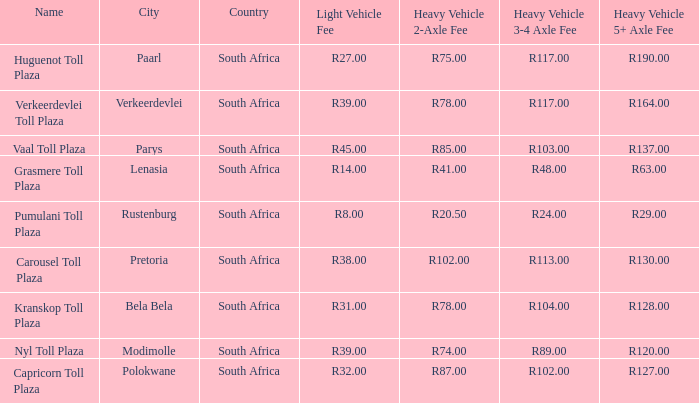What is the toll for heavy vehicles with 3/4 axles at Verkeerdevlei toll plaza? R117.00. 